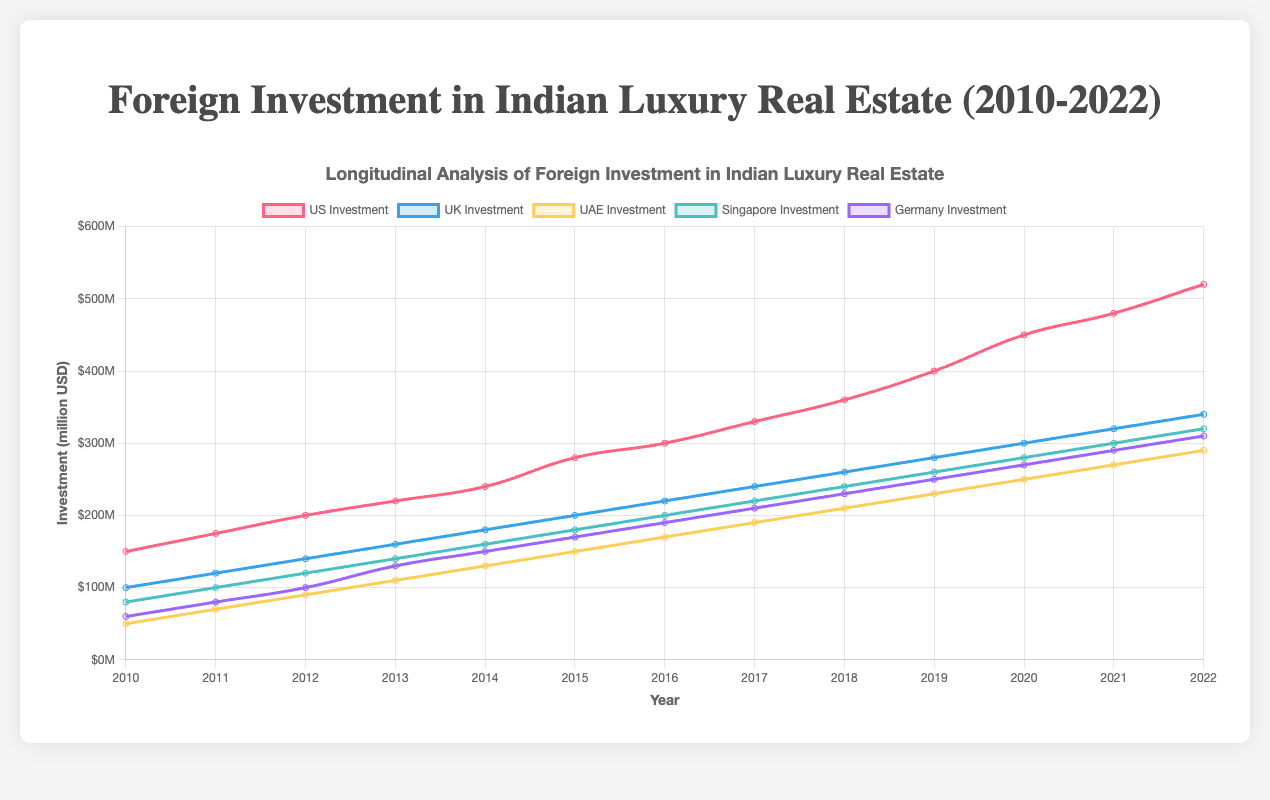Which country showed the highest foreign investment in 2022? From the chart, we observe the investment data for each country. In 2022, the US had the highest investment at $520 million.
Answer: US What is the total foreign investment from all countries in 2015? The total investment in 2015 can be calculated by summing the values for all countries for that year: $280M (US) + $200M (UK) + $150M (UAE) + $180M (Singapore) + $170M (Germany) = $980M.
Answer: $980 million Which country's investment grew the most between 2010 and 2022? By looking at the difference in investment from 2010 to 2022, the US's investment grew from $150M to $520M, an increase of $370M, which is higher than the growth in other countries.
Answer: US Compare the investments from the UK and UAE in 2019. Which is higher and by how much? The UK's investment in 2019 was $280M, and the UAE's investment was $230M. The UK's investment is $50M higher than the UAE's.
Answer: UK, $50 million What is the average annual investment from Singapore between 2010 and 2022? The average annual investment is found by summing the investments from 2010 to 2022 and then dividing by the number of years (13): ($80M + $100M + $120M + $140M + $160M + $180M + $200M + $220M + $240M + $260M + $280M + $300M + $320M) / 13 ≈ $200.77M.
Answer: Approximately $200.77 million In which year did Germany show its highest annual increase in investment compared to the previous year, and what was the value of the increase? The highest annual increase for Germany was between 2012 ($100M) and 2013 ($130M). The increase was $30M.
Answer: 2013, $30 million How does the investment trend in the US compare to that in the UK from 2010 to 2022? The US investment grows steadily with a sharper increase especially from 2014 onwards, while the UK's investment also grows steadily but at a slower rate compared to the US. The US investment starts higher and ends significantly higher.
Answer: US increased more What is the proportion of UAE investment in 2020 compared to the total investment from all countries in 2020? In 2020, UAE investment was $250M. The total investment in 2020 was $450M (US) + $300M (UK) + $250M (UAE) + $280M (Singapore) + $270M (Germany) = $1550M. The proportion is $250M / $1550M ≈ 0.161 or 16.1%.
Answer: 16.1% 